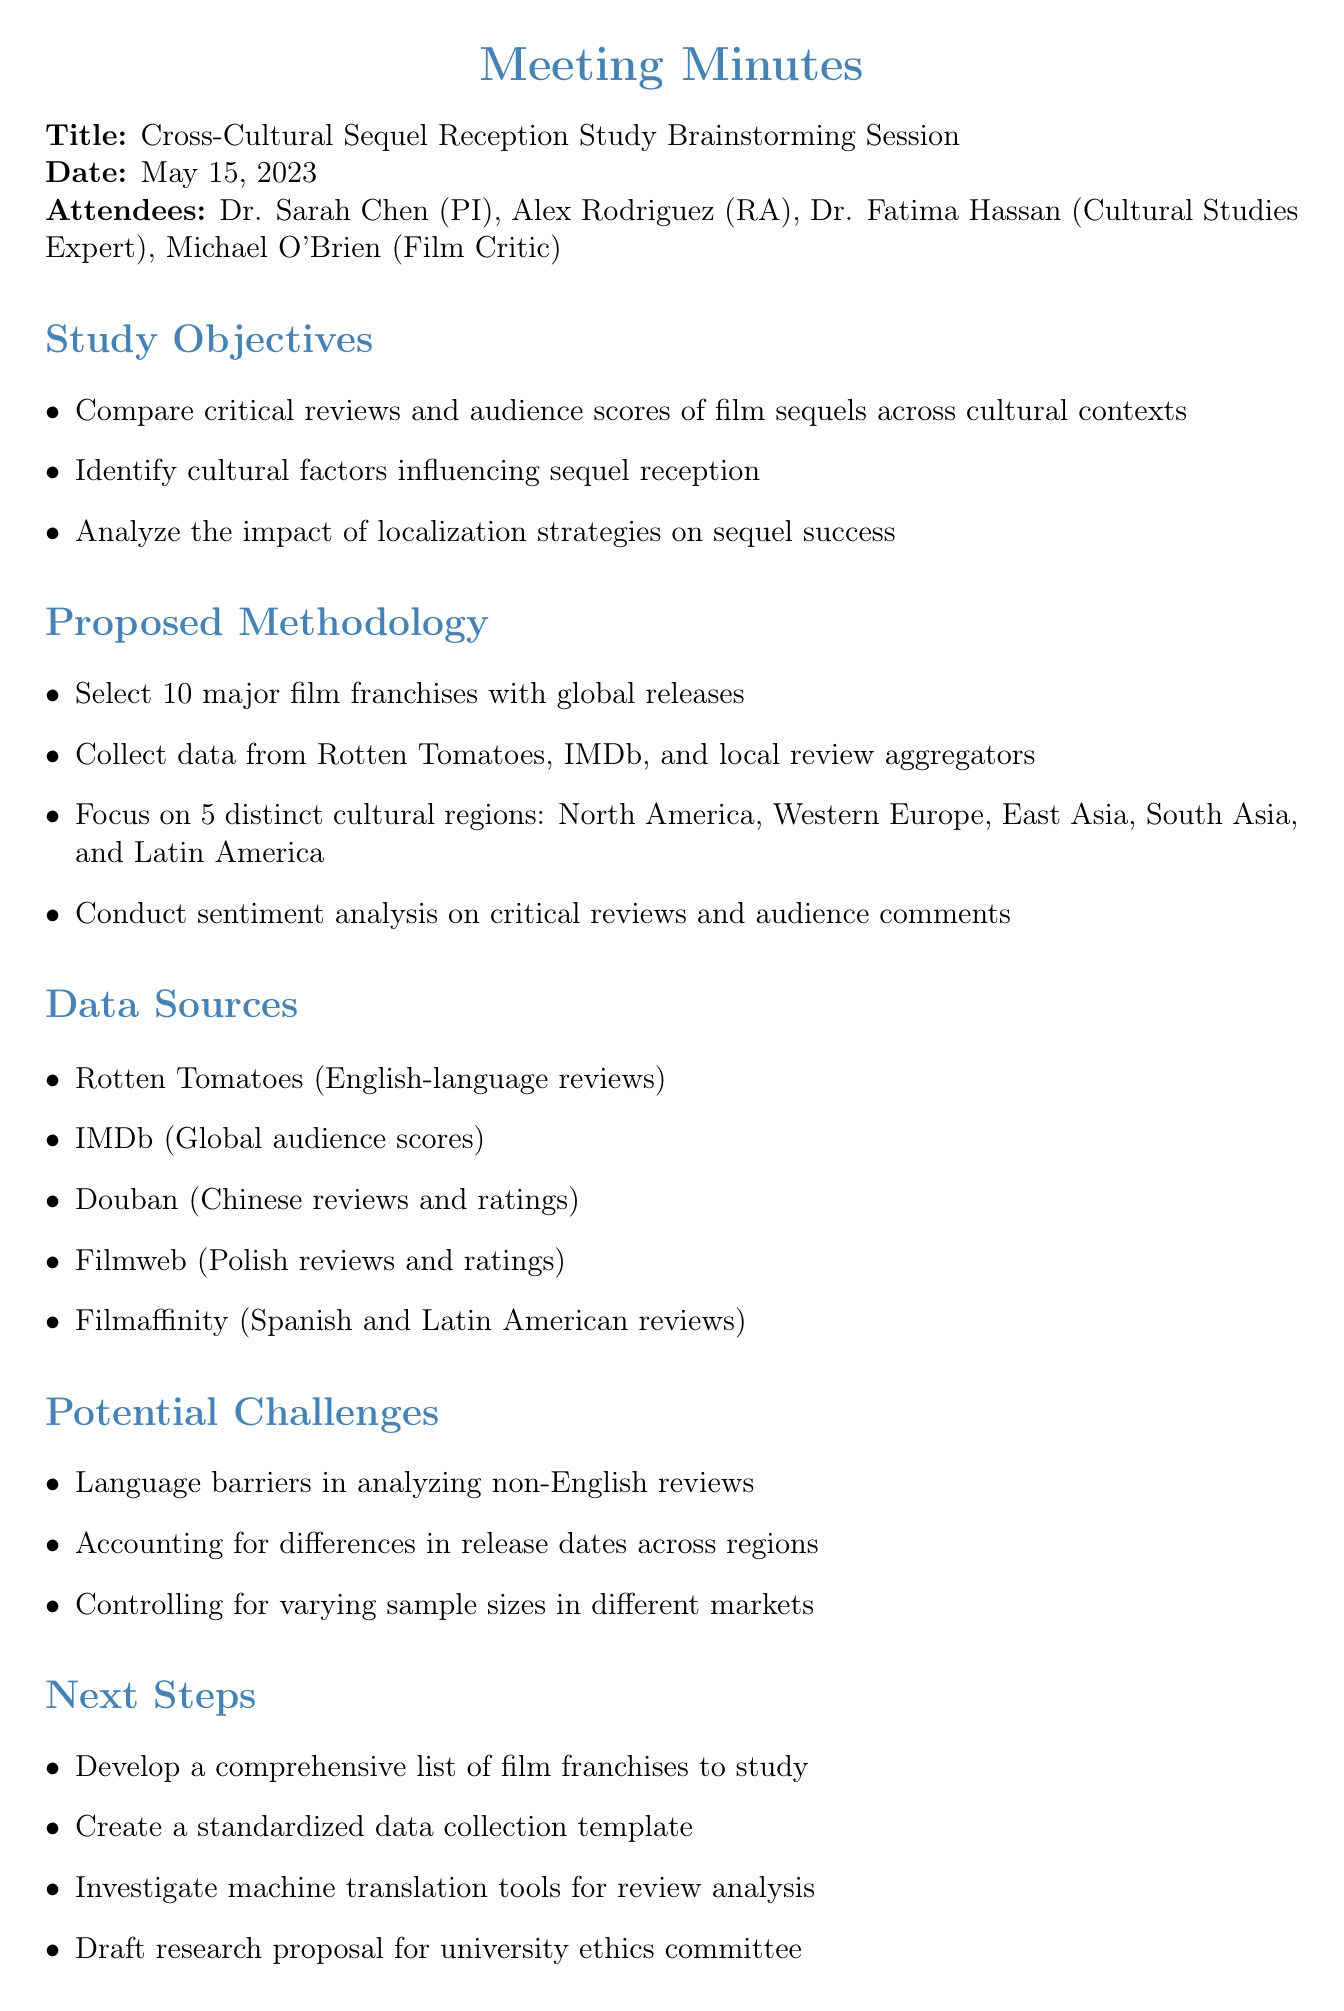What is the date of the brainstorming session? The date of the brainstorming session is explicitly mentioned in the document.
Answer: May 15, 2023 Who is the Principal Investigator? The Principal Investigator's name is listed among the attendees.
Answer: Dr. Sarah Chen How many cultural regions are being focused on in the study? The document outlines a specific number of distinct cultural regions to be analyzed in the study.
Answer: 5 What is one potential challenge mentioned in the meeting minutes? The document highlights various potential challenges that could arise during the study.
Answer: Language barriers in analyzing non-English reviews What is the first step listed under Next Steps? The next steps are clearly outlined in the agenda, with the first step specifically stated.
Answer: Develop a comprehensive list of film franchises to study Which data source provides English-language reviews? The document specifies various data sources used for the study, including one that provides English-language reviews.
Answer: Rotten Tomatoes What type of analysis will be conducted on the reviews? The methodology section describes the type of analysis planned for the reviews.
Answer: Sentiment analysis Which attendee has expertise in Cultural Studies? The document lists attendees and their respective roles, including one with a specific area of expertise.
Answer: Dr. Fatima Hassan 